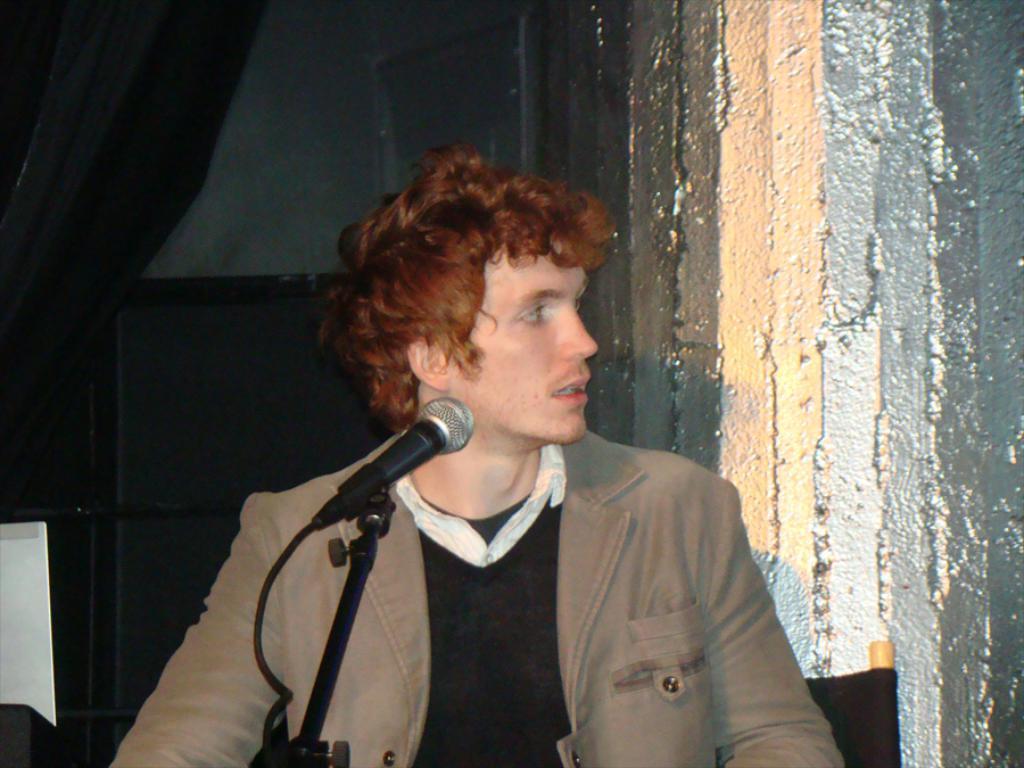How would you summarize this image in a sentence or two? A man is standing near the microphone, he wore a coat. On the right side it is a wall. 